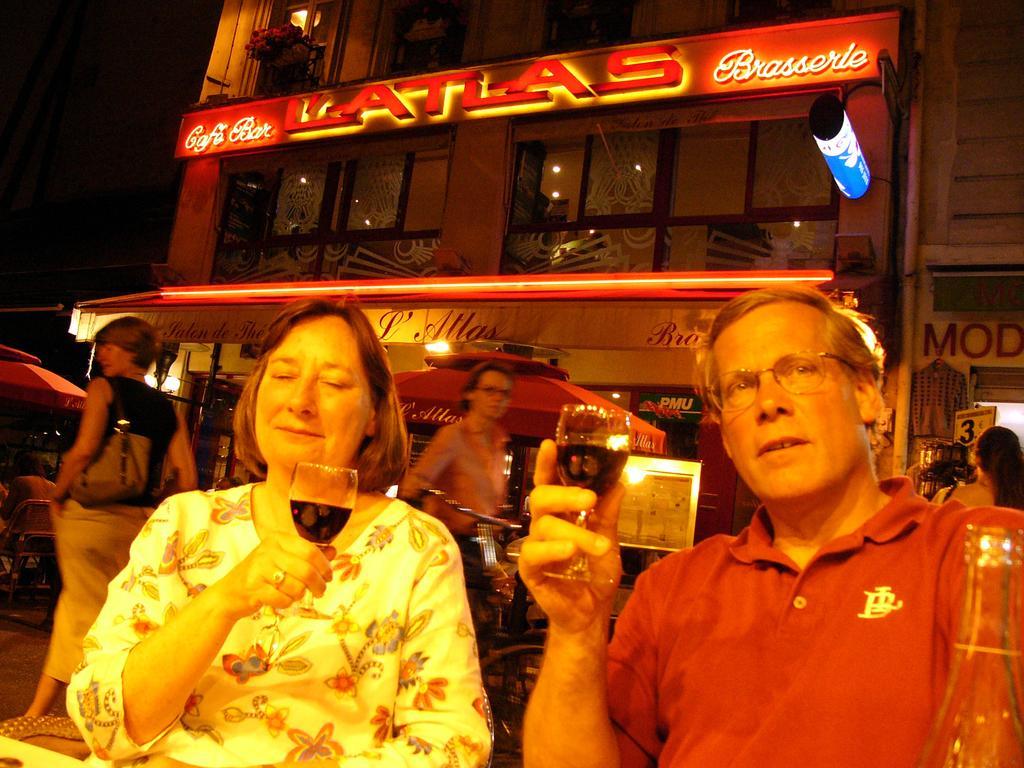Please provide a concise description of this image. 2 people are sitting holding a glass of drink. Behind them there are other people and buildings. 